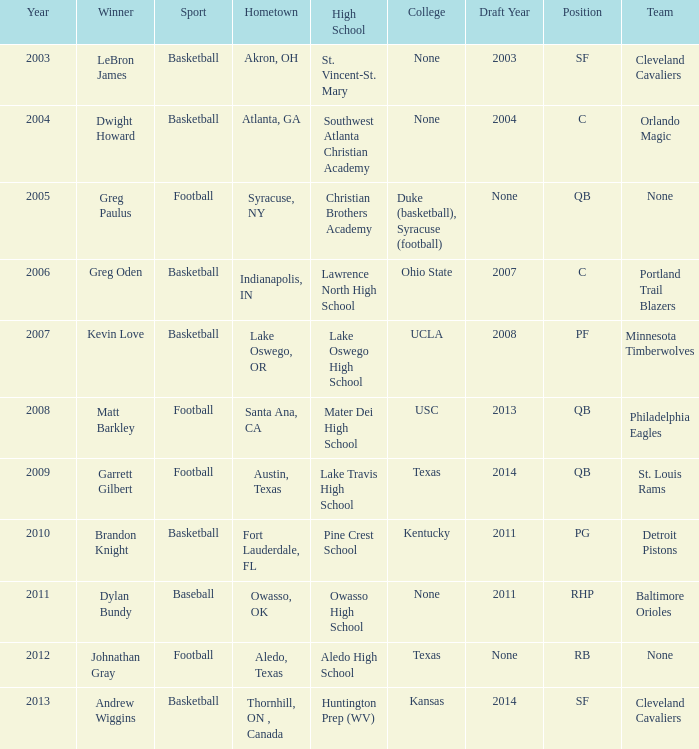Would you mind parsing the complete table? {'header': ['Year', 'Winner', 'Sport', 'Hometown', 'High School', 'College', 'Draft Year', 'Position', 'Team'], 'rows': [['2003', 'LeBron James', 'Basketball', 'Akron, OH', 'St. Vincent-St. Mary', 'None', '2003', 'SF', 'Cleveland Cavaliers'], ['2004', 'Dwight Howard', 'Basketball', 'Atlanta, GA', 'Southwest Atlanta Christian Academy', 'None', '2004', 'C', 'Orlando Magic'], ['2005', 'Greg Paulus', 'Football', 'Syracuse, NY', 'Christian Brothers Academy', 'Duke (basketball), Syracuse (football)', 'None', 'QB', 'None'], ['2006', 'Greg Oden', 'Basketball', 'Indianapolis, IN', 'Lawrence North High School', 'Ohio State', '2007', 'C', 'Portland Trail Blazers'], ['2007', 'Kevin Love', 'Basketball', 'Lake Oswego, OR', 'Lake Oswego High School', 'UCLA', '2008', 'PF', 'Minnesota Timberwolves'], ['2008', 'Matt Barkley', 'Football', 'Santa Ana, CA', 'Mater Dei High School', 'USC', '2013', 'QB', 'Philadelphia Eagles'], ['2009', 'Garrett Gilbert', 'Football', 'Austin, Texas', 'Lake Travis High School', 'Texas', '2014', 'QB', 'St. Louis Rams'], ['2010', 'Brandon Knight', 'Basketball', 'Fort Lauderdale, FL', 'Pine Crest School', 'Kentucky', '2011', 'PG', 'Detroit Pistons'], ['2011', 'Dylan Bundy', 'Baseball', 'Owasso, OK', 'Owasso High School', 'None', '2011', 'RHP', 'Baltimore Orioles'], ['2012', 'Johnathan Gray', 'Football', 'Aledo, Texas', 'Aledo High School', 'Texas', 'None', 'RB', 'None'], ['2013', 'Andrew Wiggins', 'Basketball', 'Thornhill, ON , Canada', 'Huntington Prep (WV)', 'Kansas', '2014', 'SF', 'Cleveland Cavaliers']]} What is Winner, when College is "Kentucky"? Brandon Knight. 